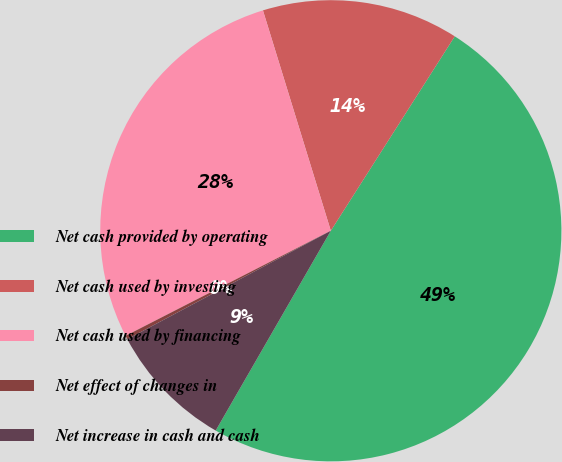Convert chart. <chart><loc_0><loc_0><loc_500><loc_500><pie_chart><fcel>Net cash provided by operating<fcel>Net cash used by investing<fcel>Net cash used by financing<fcel>Net effect of changes in<fcel>Net increase in cash and cash<nl><fcel>49.29%<fcel>13.79%<fcel>27.78%<fcel>0.26%<fcel>8.89%<nl></chart> 